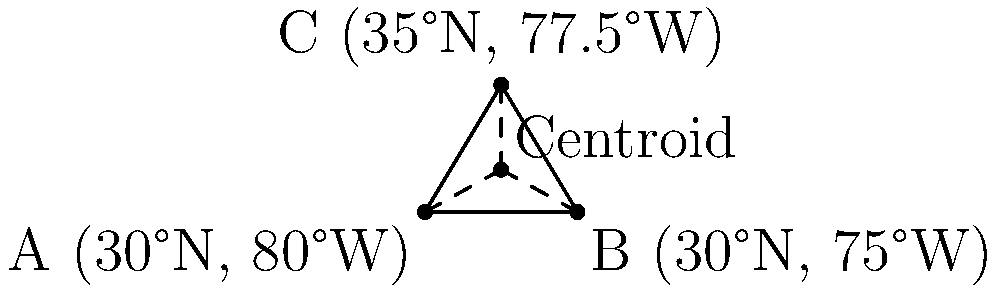Given three latitude-longitude points that define a triangular region:
A (30°N, 80°W), B (30°N, 75°W), and C (35°N, 77.5°W), calculate the coordinates of the centroid (in latitude and longitude). To find the centroid of a triangular region defined by three latitude-longitude points, we can follow these steps:

1. Convert the latitude and longitude coordinates to a Cartesian coordinate system:
   Let's assume the Earth is a perfect sphere and use the equirectangular projection for simplicity.
   
   $x = \lambda \cos(\phi)$
   $y = \phi$
   
   Where $\lambda$ is longitude and $\phi$ is latitude (both in radians).

2. Convert the given coordinates to radians:
   A: (30° * π/180, -80° * π/180) ≈ (0.5236, -1.3963)
   B: (30° * π/180, -75° * π/180) ≈ (0.5236, -1.3090)
   C: (35° * π/180, -77.5° * π/180) ≈ (0.6109, -1.3526)

3. Apply the equirectangular projection:
   A: (-1.3963 * cos(0.5236), 0.5236) ≈ (-1.2092, 0.5236)
   B: (-1.3090 * cos(0.5236), 0.5236) ≈ (-1.1335, 0.5236)
   C: (-1.3526 * cos(0.6109), 0.6109) ≈ (-1.1523, 0.6109)

4. Calculate the centroid in the Cartesian system:
   $x_{centroid} = \frac{x_A + x_B + x_C}{3} = \frac{-1.2092 + (-1.1335) + (-1.1523)}{3} ≈ -1.1650$
   $y_{centroid} = \frac{y_A + y_B + y_C}{3} = \frac{0.5236 + 0.5236 + 0.6109}{3} ≈ 0.5527$

5. Convert the centroid coordinates back to latitude and longitude:
   $\lambda_{centroid} = x_{centroid} / \cos(y_{centroid}) ≈ -1.1650 / \cos(0.5527) ≈ -1.3526$
   $\phi_{centroid} = y_{centroid} ≈ 0.5527$

6. Convert radians back to degrees:
   Latitude: $0.5527 * 180/π ≈ 31.67°$N
   Longitude: $-1.3526 * 180/π ≈ -77.50°$W

Therefore, the centroid is located at approximately (31.67°N, 77.50°W).
Answer: (31.67°N, 77.50°W) 